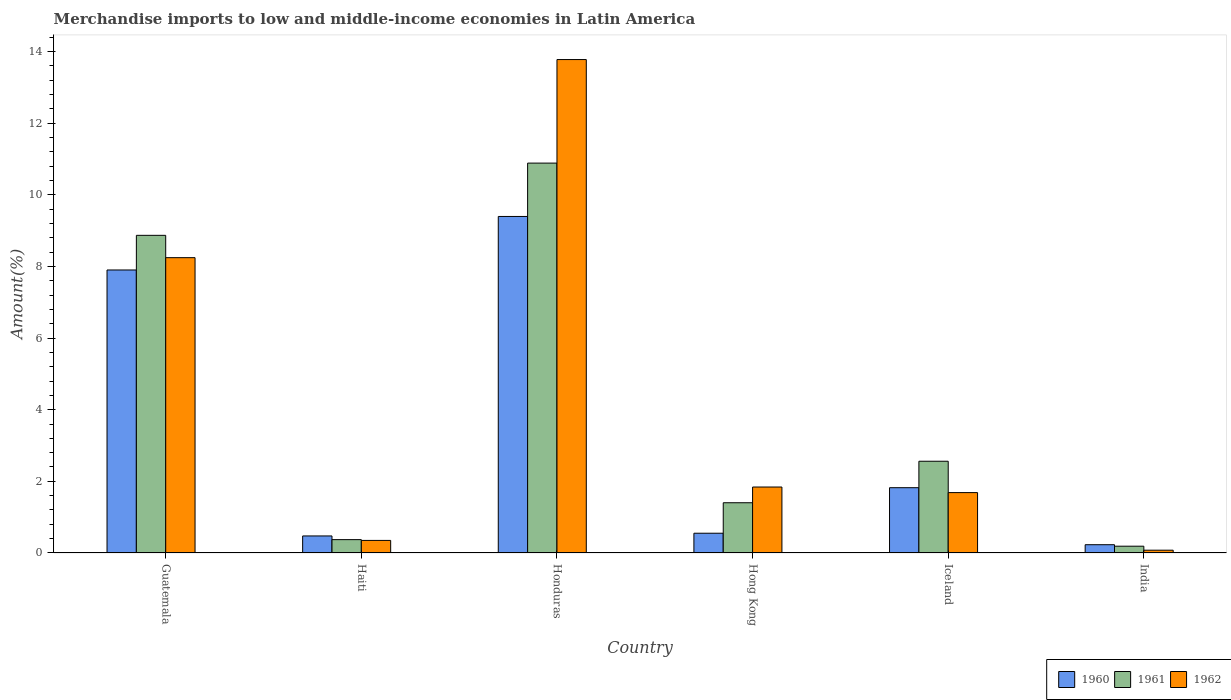Are the number of bars on each tick of the X-axis equal?
Give a very brief answer. Yes. In how many cases, is the number of bars for a given country not equal to the number of legend labels?
Keep it short and to the point. 0. What is the percentage of amount earned from merchandise imports in 1961 in India?
Your response must be concise. 0.19. Across all countries, what is the maximum percentage of amount earned from merchandise imports in 1961?
Keep it short and to the point. 10.88. Across all countries, what is the minimum percentage of amount earned from merchandise imports in 1960?
Keep it short and to the point. 0.23. In which country was the percentage of amount earned from merchandise imports in 1961 maximum?
Give a very brief answer. Honduras. In which country was the percentage of amount earned from merchandise imports in 1960 minimum?
Make the answer very short. India. What is the total percentage of amount earned from merchandise imports in 1961 in the graph?
Your answer should be very brief. 24.27. What is the difference between the percentage of amount earned from merchandise imports in 1962 in Honduras and that in Hong Kong?
Offer a terse response. 11.93. What is the difference between the percentage of amount earned from merchandise imports in 1961 in Haiti and the percentage of amount earned from merchandise imports in 1960 in Guatemala?
Offer a very short reply. -7.53. What is the average percentage of amount earned from merchandise imports in 1960 per country?
Offer a very short reply. 3.4. What is the difference between the percentage of amount earned from merchandise imports of/in 1962 and percentage of amount earned from merchandise imports of/in 1961 in Haiti?
Provide a short and direct response. -0.02. What is the ratio of the percentage of amount earned from merchandise imports in 1960 in Honduras to that in India?
Ensure brevity in your answer.  40.63. Is the percentage of amount earned from merchandise imports in 1960 in Honduras less than that in Iceland?
Make the answer very short. No. What is the difference between the highest and the second highest percentage of amount earned from merchandise imports in 1960?
Your answer should be compact. 7.57. What is the difference between the highest and the lowest percentage of amount earned from merchandise imports in 1961?
Your answer should be very brief. 10.69. What does the 1st bar from the left in Guatemala represents?
Ensure brevity in your answer.  1960. What does the 2nd bar from the right in Haiti represents?
Keep it short and to the point. 1961. Are all the bars in the graph horizontal?
Your answer should be compact. No. How many countries are there in the graph?
Your answer should be compact. 6. Are the values on the major ticks of Y-axis written in scientific E-notation?
Ensure brevity in your answer.  No. Does the graph contain any zero values?
Ensure brevity in your answer.  No. Where does the legend appear in the graph?
Keep it short and to the point. Bottom right. How many legend labels are there?
Make the answer very short. 3. How are the legend labels stacked?
Provide a short and direct response. Horizontal. What is the title of the graph?
Your answer should be compact. Merchandise imports to low and middle-income economies in Latin America. Does "1983" appear as one of the legend labels in the graph?
Your answer should be very brief. No. What is the label or title of the X-axis?
Offer a very short reply. Country. What is the label or title of the Y-axis?
Provide a succinct answer. Amount(%). What is the Amount(%) of 1960 in Guatemala?
Provide a short and direct response. 7.9. What is the Amount(%) of 1961 in Guatemala?
Provide a succinct answer. 8.87. What is the Amount(%) in 1962 in Guatemala?
Offer a terse response. 8.24. What is the Amount(%) of 1960 in Haiti?
Provide a succinct answer. 0.48. What is the Amount(%) of 1961 in Haiti?
Keep it short and to the point. 0.37. What is the Amount(%) of 1962 in Haiti?
Give a very brief answer. 0.35. What is the Amount(%) in 1960 in Honduras?
Give a very brief answer. 9.39. What is the Amount(%) of 1961 in Honduras?
Ensure brevity in your answer.  10.88. What is the Amount(%) in 1962 in Honduras?
Keep it short and to the point. 13.77. What is the Amount(%) of 1960 in Hong Kong?
Offer a terse response. 0.55. What is the Amount(%) in 1961 in Hong Kong?
Offer a very short reply. 1.4. What is the Amount(%) of 1962 in Hong Kong?
Your response must be concise. 1.84. What is the Amount(%) of 1960 in Iceland?
Provide a short and direct response. 1.82. What is the Amount(%) of 1961 in Iceland?
Ensure brevity in your answer.  2.56. What is the Amount(%) of 1962 in Iceland?
Your response must be concise. 1.69. What is the Amount(%) in 1960 in India?
Provide a short and direct response. 0.23. What is the Amount(%) in 1961 in India?
Offer a very short reply. 0.19. What is the Amount(%) in 1962 in India?
Ensure brevity in your answer.  0.08. Across all countries, what is the maximum Amount(%) in 1960?
Give a very brief answer. 9.39. Across all countries, what is the maximum Amount(%) in 1961?
Provide a succinct answer. 10.88. Across all countries, what is the maximum Amount(%) of 1962?
Your response must be concise. 13.77. Across all countries, what is the minimum Amount(%) of 1960?
Your answer should be very brief. 0.23. Across all countries, what is the minimum Amount(%) of 1961?
Provide a succinct answer. 0.19. Across all countries, what is the minimum Amount(%) of 1962?
Provide a succinct answer. 0.08. What is the total Amount(%) of 1960 in the graph?
Offer a terse response. 20.37. What is the total Amount(%) of 1961 in the graph?
Your answer should be very brief. 24.27. What is the total Amount(%) in 1962 in the graph?
Provide a short and direct response. 25.97. What is the difference between the Amount(%) of 1960 in Guatemala and that in Haiti?
Your answer should be very brief. 7.42. What is the difference between the Amount(%) of 1961 in Guatemala and that in Haiti?
Your answer should be very brief. 8.49. What is the difference between the Amount(%) of 1962 in Guatemala and that in Haiti?
Provide a short and direct response. 7.89. What is the difference between the Amount(%) of 1960 in Guatemala and that in Honduras?
Provide a succinct answer. -1.49. What is the difference between the Amount(%) in 1961 in Guatemala and that in Honduras?
Give a very brief answer. -2.02. What is the difference between the Amount(%) in 1962 in Guatemala and that in Honduras?
Offer a terse response. -5.53. What is the difference between the Amount(%) of 1960 in Guatemala and that in Hong Kong?
Offer a very short reply. 7.35. What is the difference between the Amount(%) in 1961 in Guatemala and that in Hong Kong?
Your answer should be very brief. 7.46. What is the difference between the Amount(%) in 1962 in Guatemala and that in Hong Kong?
Give a very brief answer. 6.4. What is the difference between the Amount(%) in 1960 in Guatemala and that in Iceland?
Keep it short and to the point. 6.08. What is the difference between the Amount(%) of 1961 in Guatemala and that in Iceland?
Your answer should be compact. 6.3. What is the difference between the Amount(%) of 1962 in Guatemala and that in Iceland?
Offer a very short reply. 6.56. What is the difference between the Amount(%) of 1960 in Guatemala and that in India?
Provide a short and direct response. 7.67. What is the difference between the Amount(%) in 1961 in Guatemala and that in India?
Ensure brevity in your answer.  8.68. What is the difference between the Amount(%) in 1962 in Guatemala and that in India?
Make the answer very short. 8.16. What is the difference between the Amount(%) in 1960 in Haiti and that in Honduras?
Give a very brief answer. -8.92. What is the difference between the Amount(%) of 1961 in Haiti and that in Honduras?
Make the answer very short. -10.51. What is the difference between the Amount(%) of 1962 in Haiti and that in Honduras?
Provide a short and direct response. -13.42. What is the difference between the Amount(%) in 1960 in Haiti and that in Hong Kong?
Offer a terse response. -0.08. What is the difference between the Amount(%) in 1961 in Haiti and that in Hong Kong?
Provide a short and direct response. -1.03. What is the difference between the Amount(%) of 1962 in Haiti and that in Hong Kong?
Your answer should be compact. -1.49. What is the difference between the Amount(%) of 1960 in Haiti and that in Iceland?
Give a very brief answer. -1.35. What is the difference between the Amount(%) in 1961 in Haiti and that in Iceland?
Provide a succinct answer. -2.19. What is the difference between the Amount(%) of 1962 in Haiti and that in Iceland?
Your answer should be very brief. -1.33. What is the difference between the Amount(%) in 1960 in Haiti and that in India?
Your response must be concise. 0.24. What is the difference between the Amount(%) of 1961 in Haiti and that in India?
Ensure brevity in your answer.  0.18. What is the difference between the Amount(%) in 1962 in Haiti and that in India?
Your response must be concise. 0.27. What is the difference between the Amount(%) in 1960 in Honduras and that in Hong Kong?
Your response must be concise. 8.84. What is the difference between the Amount(%) of 1961 in Honduras and that in Hong Kong?
Ensure brevity in your answer.  9.48. What is the difference between the Amount(%) in 1962 in Honduras and that in Hong Kong?
Offer a very short reply. 11.93. What is the difference between the Amount(%) in 1960 in Honduras and that in Iceland?
Give a very brief answer. 7.57. What is the difference between the Amount(%) in 1961 in Honduras and that in Iceland?
Provide a succinct answer. 8.32. What is the difference between the Amount(%) of 1962 in Honduras and that in Iceland?
Provide a succinct answer. 12.09. What is the difference between the Amount(%) in 1960 in Honduras and that in India?
Make the answer very short. 9.16. What is the difference between the Amount(%) of 1961 in Honduras and that in India?
Your answer should be compact. 10.69. What is the difference between the Amount(%) of 1962 in Honduras and that in India?
Offer a very short reply. 13.69. What is the difference between the Amount(%) of 1960 in Hong Kong and that in Iceland?
Provide a short and direct response. -1.27. What is the difference between the Amount(%) in 1961 in Hong Kong and that in Iceland?
Your answer should be very brief. -1.16. What is the difference between the Amount(%) of 1962 in Hong Kong and that in Iceland?
Provide a short and direct response. 0.16. What is the difference between the Amount(%) in 1960 in Hong Kong and that in India?
Offer a terse response. 0.32. What is the difference between the Amount(%) in 1961 in Hong Kong and that in India?
Your answer should be compact. 1.21. What is the difference between the Amount(%) in 1962 in Hong Kong and that in India?
Give a very brief answer. 1.76. What is the difference between the Amount(%) of 1960 in Iceland and that in India?
Offer a terse response. 1.59. What is the difference between the Amount(%) of 1961 in Iceland and that in India?
Provide a succinct answer. 2.37. What is the difference between the Amount(%) of 1962 in Iceland and that in India?
Your answer should be very brief. 1.61. What is the difference between the Amount(%) in 1960 in Guatemala and the Amount(%) in 1961 in Haiti?
Your answer should be compact. 7.53. What is the difference between the Amount(%) in 1960 in Guatemala and the Amount(%) in 1962 in Haiti?
Provide a succinct answer. 7.55. What is the difference between the Amount(%) of 1961 in Guatemala and the Amount(%) of 1962 in Haiti?
Keep it short and to the point. 8.51. What is the difference between the Amount(%) of 1960 in Guatemala and the Amount(%) of 1961 in Honduras?
Keep it short and to the point. -2.98. What is the difference between the Amount(%) in 1960 in Guatemala and the Amount(%) in 1962 in Honduras?
Ensure brevity in your answer.  -5.87. What is the difference between the Amount(%) in 1961 in Guatemala and the Amount(%) in 1962 in Honduras?
Provide a short and direct response. -4.91. What is the difference between the Amount(%) in 1960 in Guatemala and the Amount(%) in 1961 in Hong Kong?
Give a very brief answer. 6.5. What is the difference between the Amount(%) in 1960 in Guatemala and the Amount(%) in 1962 in Hong Kong?
Provide a short and direct response. 6.06. What is the difference between the Amount(%) of 1961 in Guatemala and the Amount(%) of 1962 in Hong Kong?
Your response must be concise. 7.02. What is the difference between the Amount(%) of 1960 in Guatemala and the Amount(%) of 1961 in Iceland?
Provide a succinct answer. 5.34. What is the difference between the Amount(%) of 1960 in Guatemala and the Amount(%) of 1962 in Iceland?
Provide a short and direct response. 6.21. What is the difference between the Amount(%) of 1961 in Guatemala and the Amount(%) of 1962 in Iceland?
Give a very brief answer. 7.18. What is the difference between the Amount(%) in 1960 in Guatemala and the Amount(%) in 1961 in India?
Your answer should be compact. 7.71. What is the difference between the Amount(%) of 1960 in Guatemala and the Amount(%) of 1962 in India?
Provide a succinct answer. 7.82. What is the difference between the Amount(%) of 1961 in Guatemala and the Amount(%) of 1962 in India?
Your answer should be very brief. 8.79. What is the difference between the Amount(%) of 1960 in Haiti and the Amount(%) of 1961 in Honduras?
Ensure brevity in your answer.  -10.41. What is the difference between the Amount(%) in 1960 in Haiti and the Amount(%) in 1962 in Honduras?
Provide a short and direct response. -13.3. What is the difference between the Amount(%) of 1961 in Haiti and the Amount(%) of 1962 in Honduras?
Give a very brief answer. -13.4. What is the difference between the Amount(%) of 1960 in Haiti and the Amount(%) of 1961 in Hong Kong?
Your response must be concise. -0.93. What is the difference between the Amount(%) of 1960 in Haiti and the Amount(%) of 1962 in Hong Kong?
Provide a succinct answer. -1.37. What is the difference between the Amount(%) in 1961 in Haiti and the Amount(%) in 1962 in Hong Kong?
Offer a terse response. -1.47. What is the difference between the Amount(%) of 1960 in Haiti and the Amount(%) of 1961 in Iceland?
Offer a terse response. -2.08. What is the difference between the Amount(%) of 1960 in Haiti and the Amount(%) of 1962 in Iceland?
Keep it short and to the point. -1.21. What is the difference between the Amount(%) of 1961 in Haiti and the Amount(%) of 1962 in Iceland?
Your answer should be very brief. -1.31. What is the difference between the Amount(%) of 1960 in Haiti and the Amount(%) of 1961 in India?
Your answer should be compact. 0.29. What is the difference between the Amount(%) in 1960 in Haiti and the Amount(%) in 1962 in India?
Your response must be concise. 0.4. What is the difference between the Amount(%) in 1961 in Haiti and the Amount(%) in 1962 in India?
Your response must be concise. 0.29. What is the difference between the Amount(%) in 1960 in Honduras and the Amount(%) in 1961 in Hong Kong?
Your response must be concise. 7.99. What is the difference between the Amount(%) of 1960 in Honduras and the Amount(%) of 1962 in Hong Kong?
Provide a short and direct response. 7.55. What is the difference between the Amount(%) of 1961 in Honduras and the Amount(%) of 1962 in Hong Kong?
Provide a succinct answer. 9.04. What is the difference between the Amount(%) of 1960 in Honduras and the Amount(%) of 1961 in Iceland?
Give a very brief answer. 6.83. What is the difference between the Amount(%) in 1960 in Honduras and the Amount(%) in 1962 in Iceland?
Your answer should be compact. 7.71. What is the difference between the Amount(%) in 1961 in Honduras and the Amount(%) in 1962 in Iceland?
Give a very brief answer. 9.2. What is the difference between the Amount(%) in 1960 in Honduras and the Amount(%) in 1961 in India?
Give a very brief answer. 9.2. What is the difference between the Amount(%) in 1960 in Honduras and the Amount(%) in 1962 in India?
Give a very brief answer. 9.31. What is the difference between the Amount(%) of 1961 in Honduras and the Amount(%) of 1962 in India?
Keep it short and to the point. 10.8. What is the difference between the Amount(%) of 1960 in Hong Kong and the Amount(%) of 1961 in Iceland?
Make the answer very short. -2.01. What is the difference between the Amount(%) in 1960 in Hong Kong and the Amount(%) in 1962 in Iceland?
Ensure brevity in your answer.  -1.13. What is the difference between the Amount(%) in 1961 in Hong Kong and the Amount(%) in 1962 in Iceland?
Keep it short and to the point. -0.28. What is the difference between the Amount(%) in 1960 in Hong Kong and the Amount(%) in 1961 in India?
Offer a terse response. 0.36. What is the difference between the Amount(%) of 1960 in Hong Kong and the Amount(%) of 1962 in India?
Provide a succinct answer. 0.47. What is the difference between the Amount(%) of 1961 in Hong Kong and the Amount(%) of 1962 in India?
Make the answer very short. 1.32. What is the difference between the Amount(%) of 1960 in Iceland and the Amount(%) of 1961 in India?
Your answer should be very brief. 1.63. What is the difference between the Amount(%) of 1960 in Iceland and the Amount(%) of 1962 in India?
Make the answer very short. 1.74. What is the difference between the Amount(%) of 1961 in Iceland and the Amount(%) of 1962 in India?
Give a very brief answer. 2.48. What is the average Amount(%) in 1960 per country?
Provide a short and direct response. 3.4. What is the average Amount(%) in 1961 per country?
Provide a succinct answer. 4.05. What is the average Amount(%) of 1962 per country?
Provide a short and direct response. 4.33. What is the difference between the Amount(%) in 1960 and Amount(%) in 1961 in Guatemala?
Your answer should be compact. -0.97. What is the difference between the Amount(%) in 1960 and Amount(%) in 1962 in Guatemala?
Provide a short and direct response. -0.34. What is the difference between the Amount(%) in 1961 and Amount(%) in 1962 in Guatemala?
Your response must be concise. 0.62. What is the difference between the Amount(%) of 1960 and Amount(%) of 1961 in Haiti?
Offer a very short reply. 0.1. What is the difference between the Amount(%) in 1960 and Amount(%) in 1962 in Haiti?
Ensure brevity in your answer.  0.12. What is the difference between the Amount(%) in 1961 and Amount(%) in 1962 in Haiti?
Ensure brevity in your answer.  0.02. What is the difference between the Amount(%) of 1960 and Amount(%) of 1961 in Honduras?
Your answer should be very brief. -1.49. What is the difference between the Amount(%) in 1960 and Amount(%) in 1962 in Honduras?
Offer a very short reply. -4.38. What is the difference between the Amount(%) of 1961 and Amount(%) of 1962 in Honduras?
Offer a terse response. -2.89. What is the difference between the Amount(%) of 1960 and Amount(%) of 1961 in Hong Kong?
Offer a very short reply. -0.85. What is the difference between the Amount(%) in 1960 and Amount(%) in 1962 in Hong Kong?
Give a very brief answer. -1.29. What is the difference between the Amount(%) in 1961 and Amount(%) in 1962 in Hong Kong?
Keep it short and to the point. -0.44. What is the difference between the Amount(%) of 1960 and Amount(%) of 1961 in Iceland?
Your answer should be very brief. -0.74. What is the difference between the Amount(%) in 1960 and Amount(%) in 1962 in Iceland?
Make the answer very short. 0.14. What is the difference between the Amount(%) in 1961 and Amount(%) in 1962 in Iceland?
Ensure brevity in your answer.  0.88. What is the difference between the Amount(%) in 1960 and Amount(%) in 1961 in India?
Provide a succinct answer. 0.04. What is the difference between the Amount(%) in 1960 and Amount(%) in 1962 in India?
Ensure brevity in your answer.  0.15. What is the difference between the Amount(%) in 1961 and Amount(%) in 1962 in India?
Provide a short and direct response. 0.11. What is the ratio of the Amount(%) in 1960 in Guatemala to that in Haiti?
Your answer should be compact. 16.61. What is the ratio of the Amount(%) in 1961 in Guatemala to that in Haiti?
Keep it short and to the point. 23.77. What is the ratio of the Amount(%) in 1962 in Guatemala to that in Haiti?
Provide a short and direct response. 23.47. What is the ratio of the Amount(%) of 1960 in Guatemala to that in Honduras?
Offer a terse response. 0.84. What is the ratio of the Amount(%) of 1961 in Guatemala to that in Honduras?
Offer a terse response. 0.81. What is the ratio of the Amount(%) in 1962 in Guatemala to that in Honduras?
Your answer should be compact. 0.6. What is the ratio of the Amount(%) of 1960 in Guatemala to that in Hong Kong?
Make the answer very short. 14.33. What is the ratio of the Amount(%) of 1961 in Guatemala to that in Hong Kong?
Provide a short and direct response. 6.32. What is the ratio of the Amount(%) of 1962 in Guatemala to that in Hong Kong?
Your answer should be compact. 4.48. What is the ratio of the Amount(%) of 1960 in Guatemala to that in Iceland?
Offer a very short reply. 4.33. What is the ratio of the Amount(%) in 1961 in Guatemala to that in Iceland?
Ensure brevity in your answer.  3.46. What is the ratio of the Amount(%) in 1962 in Guatemala to that in Iceland?
Offer a very short reply. 4.89. What is the ratio of the Amount(%) of 1960 in Guatemala to that in India?
Provide a succinct answer. 34.17. What is the ratio of the Amount(%) in 1961 in Guatemala to that in India?
Keep it short and to the point. 46.72. What is the ratio of the Amount(%) in 1962 in Guatemala to that in India?
Provide a succinct answer. 105.83. What is the ratio of the Amount(%) in 1960 in Haiti to that in Honduras?
Make the answer very short. 0.05. What is the ratio of the Amount(%) in 1961 in Haiti to that in Honduras?
Provide a short and direct response. 0.03. What is the ratio of the Amount(%) in 1962 in Haiti to that in Honduras?
Your answer should be very brief. 0.03. What is the ratio of the Amount(%) of 1960 in Haiti to that in Hong Kong?
Your answer should be compact. 0.86. What is the ratio of the Amount(%) of 1961 in Haiti to that in Hong Kong?
Your response must be concise. 0.27. What is the ratio of the Amount(%) in 1962 in Haiti to that in Hong Kong?
Offer a terse response. 0.19. What is the ratio of the Amount(%) in 1960 in Haiti to that in Iceland?
Provide a succinct answer. 0.26. What is the ratio of the Amount(%) of 1961 in Haiti to that in Iceland?
Offer a terse response. 0.15. What is the ratio of the Amount(%) of 1962 in Haiti to that in Iceland?
Make the answer very short. 0.21. What is the ratio of the Amount(%) in 1960 in Haiti to that in India?
Provide a short and direct response. 2.06. What is the ratio of the Amount(%) in 1961 in Haiti to that in India?
Provide a short and direct response. 1.97. What is the ratio of the Amount(%) of 1962 in Haiti to that in India?
Offer a very short reply. 4.51. What is the ratio of the Amount(%) in 1960 in Honduras to that in Hong Kong?
Provide a succinct answer. 17.03. What is the ratio of the Amount(%) of 1961 in Honduras to that in Hong Kong?
Keep it short and to the point. 7.76. What is the ratio of the Amount(%) of 1962 in Honduras to that in Hong Kong?
Provide a succinct answer. 7.48. What is the ratio of the Amount(%) of 1960 in Honduras to that in Iceland?
Offer a very short reply. 5.15. What is the ratio of the Amount(%) of 1961 in Honduras to that in Iceland?
Offer a very short reply. 4.25. What is the ratio of the Amount(%) of 1962 in Honduras to that in Iceland?
Keep it short and to the point. 8.17. What is the ratio of the Amount(%) in 1960 in Honduras to that in India?
Offer a very short reply. 40.63. What is the ratio of the Amount(%) in 1961 in Honduras to that in India?
Your answer should be very brief. 57.34. What is the ratio of the Amount(%) of 1962 in Honduras to that in India?
Ensure brevity in your answer.  176.83. What is the ratio of the Amount(%) in 1960 in Hong Kong to that in Iceland?
Your answer should be very brief. 0.3. What is the ratio of the Amount(%) in 1961 in Hong Kong to that in Iceland?
Provide a succinct answer. 0.55. What is the ratio of the Amount(%) in 1962 in Hong Kong to that in Iceland?
Provide a short and direct response. 1.09. What is the ratio of the Amount(%) of 1960 in Hong Kong to that in India?
Your answer should be compact. 2.39. What is the ratio of the Amount(%) in 1961 in Hong Kong to that in India?
Offer a terse response. 7.39. What is the ratio of the Amount(%) in 1962 in Hong Kong to that in India?
Provide a short and direct response. 23.64. What is the ratio of the Amount(%) in 1960 in Iceland to that in India?
Provide a short and direct response. 7.88. What is the ratio of the Amount(%) of 1961 in Iceland to that in India?
Keep it short and to the point. 13.49. What is the ratio of the Amount(%) of 1962 in Iceland to that in India?
Keep it short and to the point. 21.64. What is the difference between the highest and the second highest Amount(%) in 1960?
Your answer should be very brief. 1.49. What is the difference between the highest and the second highest Amount(%) of 1961?
Provide a short and direct response. 2.02. What is the difference between the highest and the second highest Amount(%) in 1962?
Offer a very short reply. 5.53. What is the difference between the highest and the lowest Amount(%) in 1960?
Your response must be concise. 9.16. What is the difference between the highest and the lowest Amount(%) in 1961?
Ensure brevity in your answer.  10.69. What is the difference between the highest and the lowest Amount(%) of 1962?
Your answer should be compact. 13.69. 